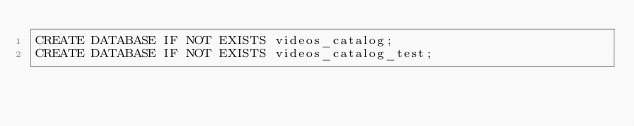<code> <loc_0><loc_0><loc_500><loc_500><_SQL_>CREATE DATABASE IF NOT EXISTS videos_catalog;
CREATE DATABASE IF NOT EXISTS videos_catalog_test;
</code> 